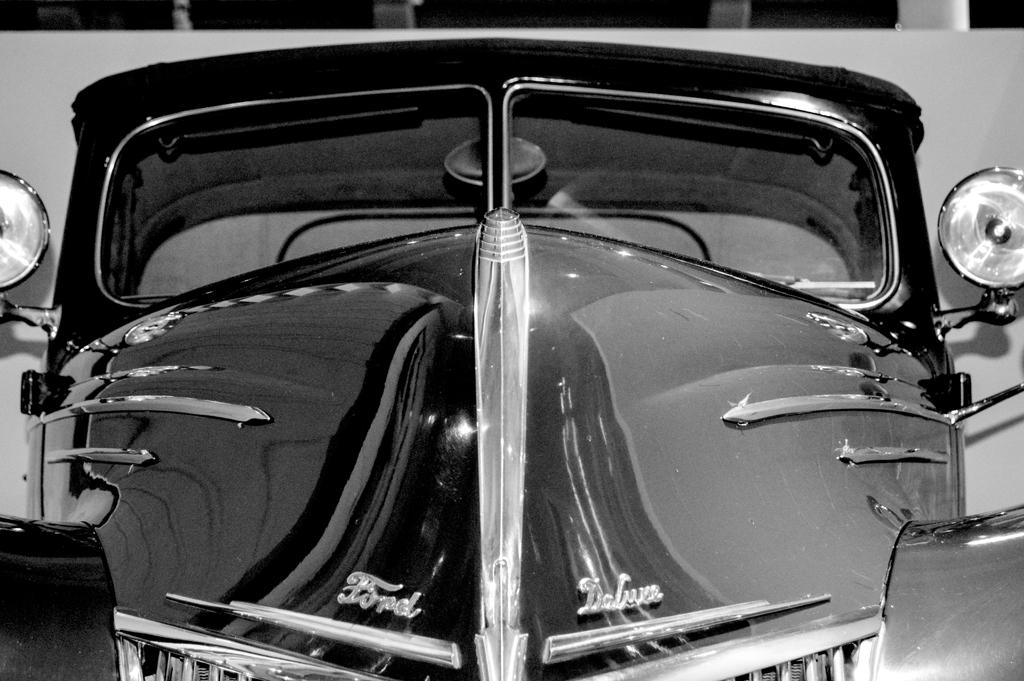What is the color scheme of the image? The image is black and white. What is the main subject of the image? There is a car in the image. Which part of the car can be seen in the image? Only the front part of the car is visible. Is there any text on the car? Yes, there is text on the car. What is behind the car in the image? There is a wall behind the car. What is the person thinking about while sitting on the park bench in the image? There is no person or park bench present in the image; it only features a black and white car with text and a wall in the background. 